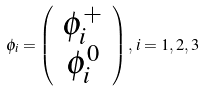Convert formula to latex. <formula><loc_0><loc_0><loc_500><loc_500>\phi _ { i } = \left ( \begin{array} { c } { { \phi _ { i } ^ { + } } } \\ { { \phi _ { i } ^ { 0 } } } \end{array} \right ) , \, i = 1 , 2 , 3</formula> 